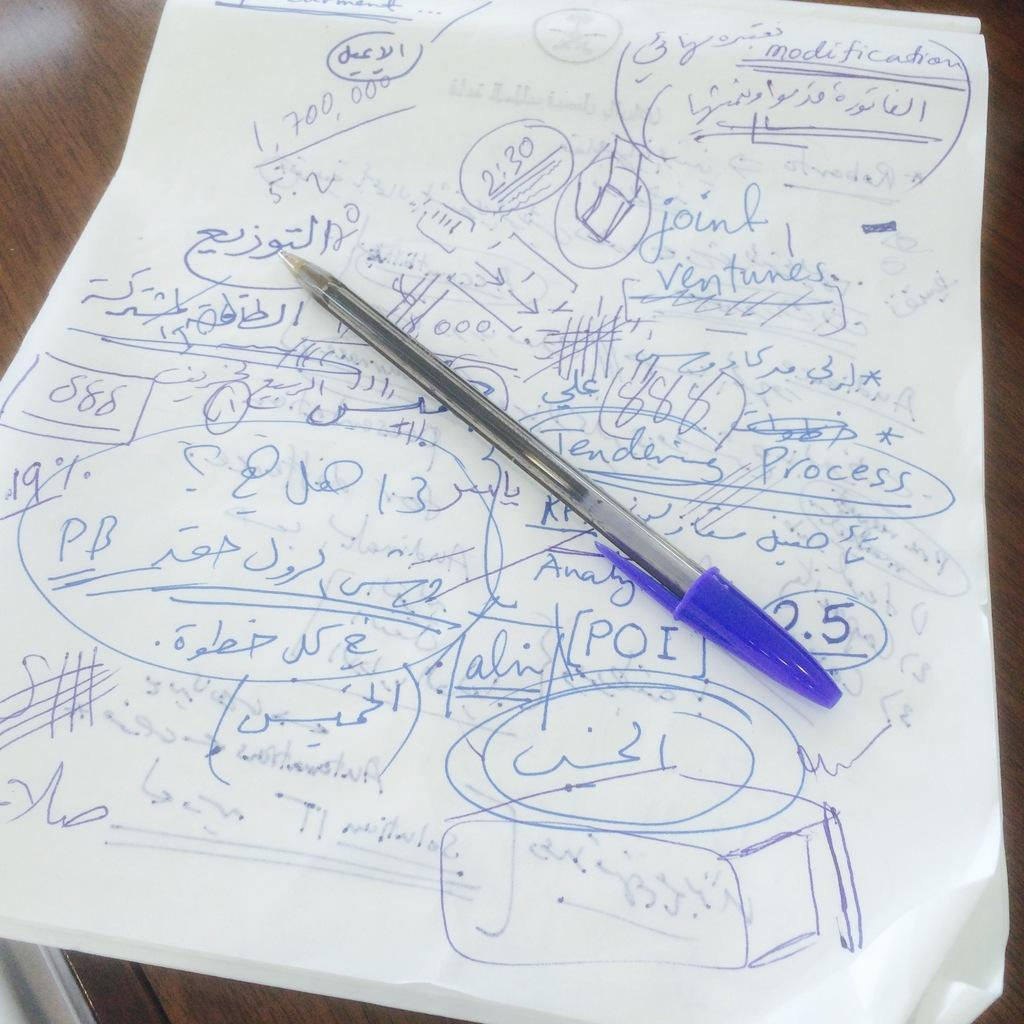What is placed on the paper in the image? There is a pen on a paper in the image. What is the surface on which the pen and paper are placed? The pen and paper are on a wooden surface. What is the name of the person who wrote on the paper in the image? There is no indication in the image of who might have written on the paper, so it cannot be determined from the picture. How many apples are visible on the wooden surface in the image? There are no apples present in the image. What type of blade is being used to write on the paper in the image? There is no blade visible in the image; only a pen is present. 